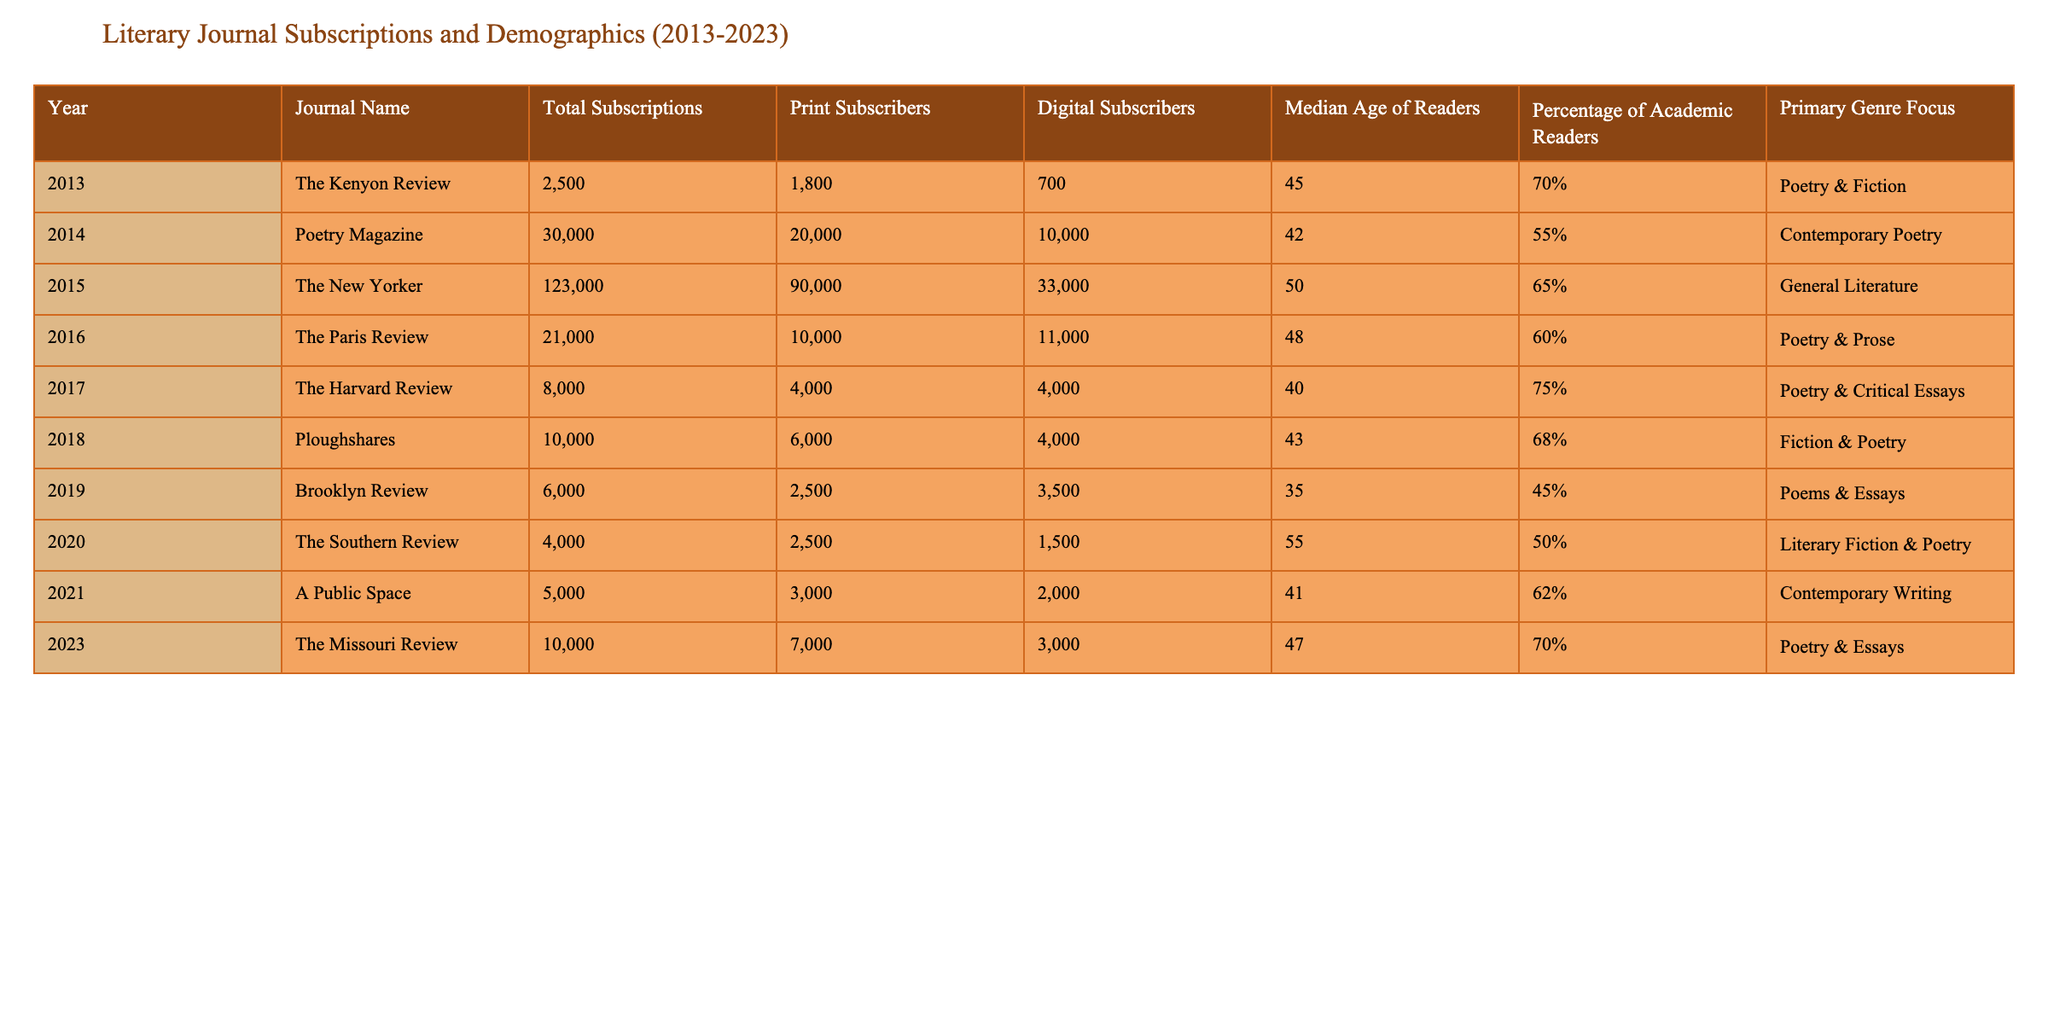What is the total number of subscriptions for Poetry Magazine in 2014? The table shows that in 2014, Poetry Magazine had a total of 30,000 subscriptions.
Answer: 30,000 Which journal had the highest number of print subscribers in 2015? The table indicates that in 2015, The New Yorker had 90,000 print subscribers, which is the highest among the journals listed for that year.
Answer: The New Yorker What is the median age of readers for The Harvard Review in 2017? According to the table, The Harvard Review had a median age of readers of 40 in 2017.
Answer: 40 How many total subscriptions did The Missouri Review have? The table reveals that The Missouri Review had a total of 10,000 subscriptions.
Answer: 10,000 What is the percentage of academic readers for The Paris Review in 2016? The table specifies that The Paris Review had 60% of its readers classified as academic in 2016.
Answer: 60% How many more total subscriptions did The New Yorker have compared to The Southern Review in 2020? The New Yorker had 123,000 subscriptions in 2015, while The Southern Review had 4,000 in 2020. The difference is 123,000 - 4,000 = 119,000.
Answer: 119,000 What is the average median age of readers across all the journals listed? To find the average, sum the median ages (45, 42, 50, 48, 40, 43, 35, 55, 41, 47) which equals  423. This is divided by the total number of journals, which is 10, so the average is 423 / 10 = 42.3.
Answer: 42.3 Which journal has the least percentage of academic readers and what is that percentage? The Brooklyn Review in 2019 had the least percentage of academic readers at 45%.
Answer: 45% Is the primary genre focus of The Southern Review literary fiction and poetry? Based on the table, the primary genre focus of The Southern Review is indeed literary fiction and poetry.
Answer: Yes What is the difference in total subscriptions between The Kenyon Review and Ploughshares? The Kenyon Review had 2,500 subscriptions, while Ploughshares had 10,000 subscriptions in different years. The difference is 10,000 - 2,500 = 7,500.
Answer: 7,500 